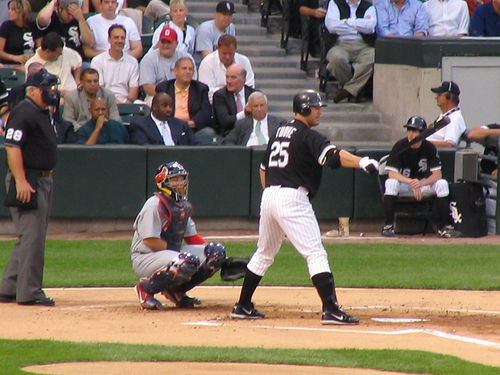Identify and read out the text in this image. 25 88 S S S X 